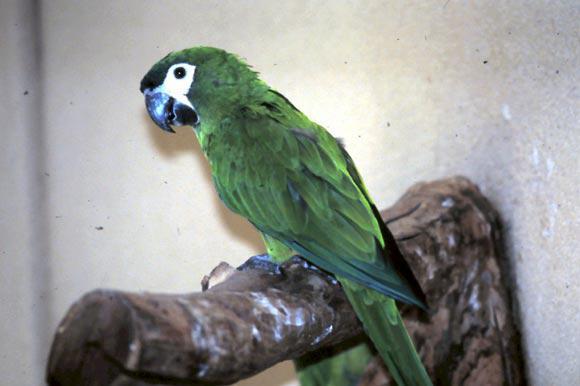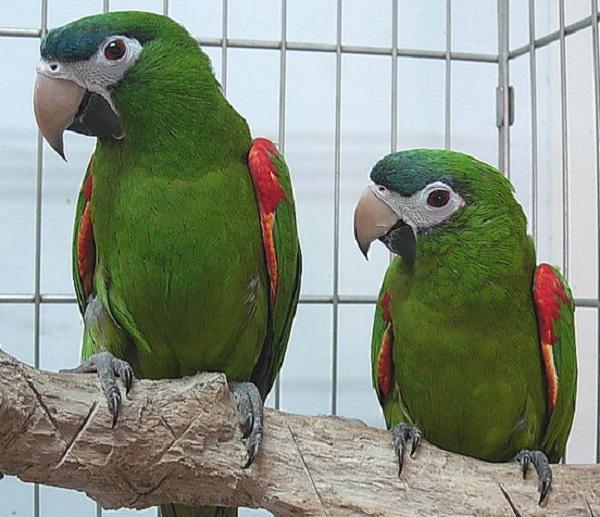The first image is the image on the left, the second image is the image on the right. Given the left and right images, does the statement "There are two parrots in total, both with predominantly green feathers." hold true? Answer yes or no. No. The first image is the image on the left, the second image is the image on the right. Given the left and right images, does the statement "An image contains one right-facing parrot in front of a mesh." hold true? Answer yes or no. No. 